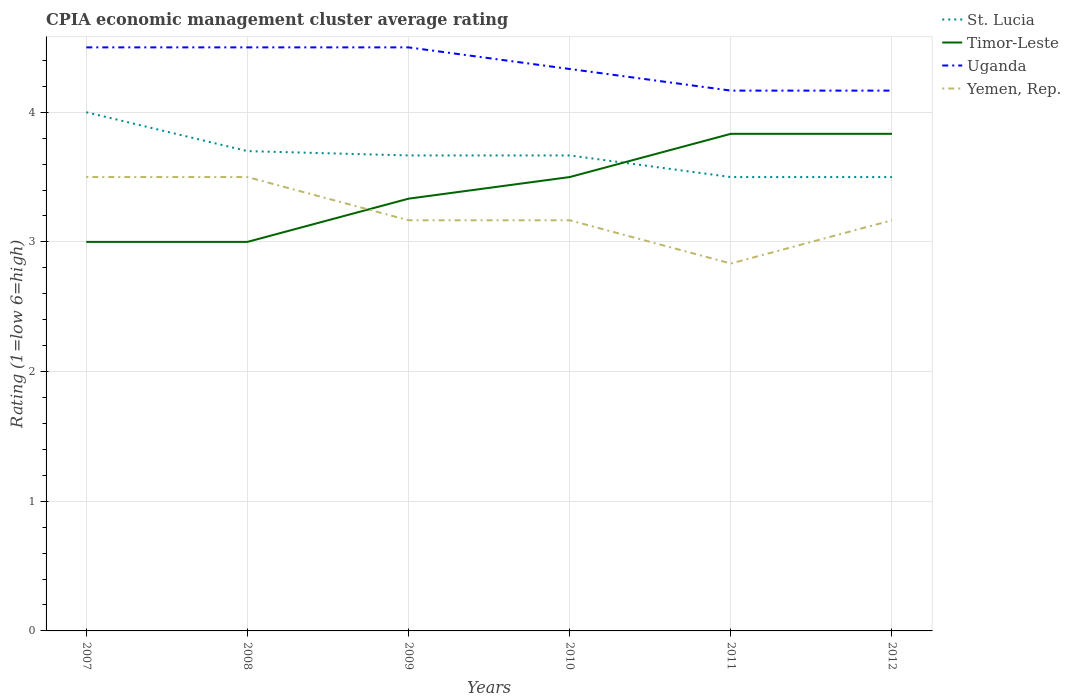How many different coloured lines are there?
Give a very brief answer. 4. Across all years, what is the maximum CPIA rating in St. Lucia?
Offer a very short reply. 3.5. In which year was the CPIA rating in Yemen, Rep. maximum?
Offer a very short reply. 2011. What is the total CPIA rating in Uganda in the graph?
Give a very brief answer. 0.33. What is the difference between the highest and the second highest CPIA rating in Uganda?
Provide a short and direct response. 0.33. What is the difference between the highest and the lowest CPIA rating in Timor-Leste?
Ensure brevity in your answer.  3. Is the CPIA rating in Uganda strictly greater than the CPIA rating in Yemen, Rep. over the years?
Offer a very short reply. No. What is the difference between two consecutive major ticks on the Y-axis?
Keep it short and to the point. 1. Are the values on the major ticks of Y-axis written in scientific E-notation?
Your answer should be very brief. No. Does the graph contain any zero values?
Provide a short and direct response. No. Does the graph contain grids?
Offer a terse response. Yes. Where does the legend appear in the graph?
Provide a succinct answer. Top right. What is the title of the graph?
Offer a terse response. CPIA economic management cluster average rating. What is the label or title of the Y-axis?
Offer a terse response. Rating (1=low 6=high). What is the Rating (1=low 6=high) of Timor-Leste in 2007?
Your answer should be compact. 3. What is the Rating (1=low 6=high) in Yemen, Rep. in 2007?
Make the answer very short. 3.5. What is the Rating (1=low 6=high) in St. Lucia in 2008?
Offer a terse response. 3.7. What is the Rating (1=low 6=high) of Timor-Leste in 2008?
Make the answer very short. 3. What is the Rating (1=low 6=high) in Yemen, Rep. in 2008?
Your answer should be compact. 3.5. What is the Rating (1=low 6=high) in St. Lucia in 2009?
Ensure brevity in your answer.  3.67. What is the Rating (1=low 6=high) of Timor-Leste in 2009?
Make the answer very short. 3.33. What is the Rating (1=low 6=high) of Uganda in 2009?
Provide a succinct answer. 4.5. What is the Rating (1=low 6=high) of Yemen, Rep. in 2009?
Your answer should be very brief. 3.17. What is the Rating (1=low 6=high) in St. Lucia in 2010?
Keep it short and to the point. 3.67. What is the Rating (1=low 6=high) in Timor-Leste in 2010?
Ensure brevity in your answer.  3.5. What is the Rating (1=low 6=high) of Uganda in 2010?
Your answer should be compact. 4.33. What is the Rating (1=low 6=high) in Yemen, Rep. in 2010?
Your answer should be very brief. 3.17. What is the Rating (1=low 6=high) of St. Lucia in 2011?
Give a very brief answer. 3.5. What is the Rating (1=low 6=high) of Timor-Leste in 2011?
Make the answer very short. 3.83. What is the Rating (1=low 6=high) of Uganda in 2011?
Offer a very short reply. 4.17. What is the Rating (1=low 6=high) in Yemen, Rep. in 2011?
Your answer should be very brief. 2.83. What is the Rating (1=low 6=high) in St. Lucia in 2012?
Your response must be concise. 3.5. What is the Rating (1=low 6=high) in Timor-Leste in 2012?
Provide a succinct answer. 3.83. What is the Rating (1=low 6=high) of Uganda in 2012?
Provide a short and direct response. 4.17. What is the Rating (1=low 6=high) of Yemen, Rep. in 2012?
Your answer should be very brief. 3.17. Across all years, what is the maximum Rating (1=low 6=high) of Timor-Leste?
Give a very brief answer. 3.83. Across all years, what is the maximum Rating (1=low 6=high) of Uganda?
Offer a very short reply. 4.5. Across all years, what is the maximum Rating (1=low 6=high) of Yemen, Rep.?
Make the answer very short. 3.5. Across all years, what is the minimum Rating (1=low 6=high) of St. Lucia?
Make the answer very short. 3.5. Across all years, what is the minimum Rating (1=low 6=high) in Timor-Leste?
Your response must be concise. 3. Across all years, what is the minimum Rating (1=low 6=high) of Uganda?
Make the answer very short. 4.17. Across all years, what is the minimum Rating (1=low 6=high) in Yemen, Rep.?
Offer a terse response. 2.83. What is the total Rating (1=low 6=high) of St. Lucia in the graph?
Your answer should be very brief. 22.03. What is the total Rating (1=low 6=high) in Timor-Leste in the graph?
Your answer should be very brief. 20.5. What is the total Rating (1=low 6=high) in Uganda in the graph?
Offer a very short reply. 26.17. What is the total Rating (1=low 6=high) in Yemen, Rep. in the graph?
Offer a very short reply. 19.33. What is the difference between the Rating (1=low 6=high) in Uganda in 2007 and that in 2008?
Offer a terse response. 0. What is the difference between the Rating (1=low 6=high) in Timor-Leste in 2007 and that in 2009?
Keep it short and to the point. -0.33. What is the difference between the Rating (1=low 6=high) in Yemen, Rep. in 2007 and that in 2009?
Provide a short and direct response. 0.33. What is the difference between the Rating (1=low 6=high) of Timor-Leste in 2007 and that in 2010?
Give a very brief answer. -0.5. What is the difference between the Rating (1=low 6=high) in St. Lucia in 2007 and that in 2011?
Ensure brevity in your answer.  0.5. What is the difference between the Rating (1=low 6=high) of Yemen, Rep. in 2007 and that in 2011?
Give a very brief answer. 0.67. What is the difference between the Rating (1=low 6=high) in Timor-Leste in 2007 and that in 2012?
Your answer should be very brief. -0.83. What is the difference between the Rating (1=low 6=high) of St. Lucia in 2008 and that in 2009?
Your response must be concise. 0.03. What is the difference between the Rating (1=low 6=high) of Timor-Leste in 2008 and that in 2009?
Keep it short and to the point. -0.33. What is the difference between the Rating (1=low 6=high) of St. Lucia in 2008 and that in 2010?
Give a very brief answer. 0.03. What is the difference between the Rating (1=low 6=high) of Yemen, Rep. in 2008 and that in 2011?
Your response must be concise. 0.67. What is the difference between the Rating (1=low 6=high) of Timor-Leste in 2008 and that in 2012?
Give a very brief answer. -0.83. What is the difference between the Rating (1=low 6=high) of Uganda in 2008 and that in 2012?
Make the answer very short. 0.33. What is the difference between the Rating (1=low 6=high) in St. Lucia in 2009 and that in 2010?
Your answer should be very brief. 0. What is the difference between the Rating (1=low 6=high) of Uganda in 2009 and that in 2010?
Provide a short and direct response. 0.17. What is the difference between the Rating (1=low 6=high) in Yemen, Rep. in 2009 and that in 2010?
Your answer should be compact. 0. What is the difference between the Rating (1=low 6=high) in Timor-Leste in 2009 and that in 2012?
Your response must be concise. -0.5. What is the difference between the Rating (1=low 6=high) in St. Lucia in 2010 and that in 2011?
Offer a terse response. 0.17. What is the difference between the Rating (1=low 6=high) in Yemen, Rep. in 2010 and that in 2011?
Keep it short and to the point. 0.33. What is the difference between the Rating (1=low 6=high) in Yemen, Rep. in 2010 and that in 2012?
Ensure brevity in your answer.  0. What is the difference between the Rating (1=low 6=high) in St. Lucia in 2011 and that in 2012?
Your answer should be very brief. 0. What is the difference between the Rating (1=low 6=high) of St. Lucia in 2007 and the Rating (1=low 6=high) of Timor-Leste in 2008?
Offer a very short reply. 1. What is the difference between the Rating (1=low 6=high) of St. Lucia in 2007 and the Rating (1=low 6=high) of Uganda in 2008?
Your answer should be very brief. -0.5. What is the difference between the Rating (1=low 6=high) of St. Lucia in 2007 and the Rating (1=low 6=high) of Yemen, Rep. in 2008?
Your response must be concise. 0.5. What is the difference between the Rating (1=low 6=high) in Timor-Leste in 2007 and the Rating (1=low 6=high) in Uganda in 2008?
Your answer should be very brief. -1.5. What is the difference between the Rating (1=low 6=high) of Uganda in 2007 and the Rating (1=low 6=high) of Yemen, Rep. in 2008?
Your response must be concise. 1. What is the difference between the Rating (1=low 6=high) of St. Lucia in 2007 and the Rating (1=low 6=high) of Uganda in 2009?
Ensure brevity in your answer.  -0.5. What is the difference between the Rating (1=low 6=high) of St. Lucia in 2007 and the Rating (1=low 6=high) of Yemen, Rep. in 2009?
Ensure brevity in your answer.  0.83. What is the difference between the Rating (1=low 6=high) of St. Lucia in 2007 and the Rating (1=low 6=high) of Timor-Leste in 2010?
Your answer should be very brief. 0.5. What is the difference between the Rating (1=low 6=high) of St. Lucia in 2007 and the Rating (1=low 6=high) of Yemen, Rep. in 2010?
Make the answer very short. 0.83. What is the difference between the Rating (1=low 6=high) of Timor-Leste in 2007 and the Rating (1=low 6=high) of Uganda in 2010?
Ensure brevity in your answer.  -1.33. What is the difference between the Rating (1=low 6=high) of Timor-Leste in 2007 and the Rating (1=low 6=high) of Yemen, Rep. in 2010?
Give a very brief answer. -0.17. What is the difference between the Rating (1=low 6=high) in Timor-Leste in 2007 and the Rating (1=low 6=high) in Uganda in 2011?
Provide a succinct answer. -1.17. What is the difference between the Rating (1=low 6=high) of St. Lucia in 2007 and the Rating (1=low 6=high) of Uganda in 2012?
Provide a short and direct response. -0.17. What is the difference between the Rating (1=low 6=high) of Timor-Leste in 2007 and the Rating (1=low 6=high) of Uganda in 2012?
Your answer should be very brief. -1.17. What is the difference between the Rating (1=low 6=high) in Uganda in 2007 and the Rating (1=low 6=high) in Yemen, Rep. in 2012?
Give a very brief answer. 1.33. What is the difference between the Rating (1=low 6=high) of St. Lucia in 2008 and the Rating (1=low 6=high) of Timor-Leste in 2009?
Offer a very short reply. 0.37. What is the difference between the Rating (1=low 6=high) in St. Lucia in 2008 and the Rating (1=low 6=high) in Yemen, Rep. in 2009?
Your answer should be very brief. 0.53. What is the difference between the Rating (1=low 6=high) of Uganda in 2008 and the Rating (1=low 6=high) of Yemen, Rep. in 2009?
Your answer should be compact. 1.33. What is the difference between the Rating (1=low 6=high) of St. Lucia in 2008 and the Rating (1=low 6=high) of Timor-Leste in 2010?
Give a very brief answer. 0.2. What is the difference between the Rating (1=low 6=high) of St. Lucia in 2008 and the Rating (1=low 6=high) of Uganda in 2010?
Offer a terse response. -0.63. What is the difference between the Rating (1=low 6=high) of St. Lucia in 2008 and the Rating (1=low 6=high) of Yemen, Rep. in 2010?
Your response must be concise. 0.53. What is the difference between the Rating (1=low 6=high) of Timor-Leste in 2008 and the Rating (1=low 6=high) of Uganda in 2010?
Your response must be concise. -1.33. What is the difference between the Rating (1=low 6=high) in St. Lucia in 2008 and the Rating (1=low 6=high) in Timor-Leste in 2011?
Make the answer very short. -0.13. What is the difference between the Rating (1=low 6=high) of St. Lucia in 2008 and the Rating (1=low 6=high) of Uganda in 2011?
Offer a very short reply. -0.47. What is the difference between the Rating (1=low 6=high) of St. Lucia in 2008 and the Rating (1=low 6=high) of Yemen, Rep. in 2011?
Your answer should be compact. 0.87. What is the difference between the Rating (1=low 6=high) in Timor-Leste in 2008 and the Rating (1=low 6=high) in Uganda in 2011?
Provide a succinct answer. -1.17. What is the difference between the Rating (1=low 6=high) of Timor-Leste in 2008 and the Rating (1=low 6=high) of Yemen, Rep. in 2011?
Make the answer very short. 0.17. What is the difference between the Rating (1=low 6=high) in Uganda in 2008 and the Rating (1=low 6=high) in Yemen, Rep. in 2011?
Keep it short and to the point. 1.67. What is the difference between the Rating (1=low 6=high) of St. Lucia in 2008 and the Rating (1=low 6=high) of Timor-Leste in 2012?
Keep it short and to the point. -0.13. What is the difference between the Rating (1=low 6=high) in St. Lucia in 2008 and the Rating (1=low 6=high) in Uganda in 2012?
Provide a short and direct response. -0.47. What is the difference between the Rating (1=low 6=high) of St. Lucia in 2008 and the Rating (1=low 6=high) of Yemen, Rep. in 2012?
Your answer should be very brief. 0.53. What is the difference between the Rating (1=low 6=high) of Timor-Leste in 2008 and the Rating (1=low 6=high) of Uganda in 2012?
Make the answer very short. -1.17. What is the difference between the Rating (1=low 6=high) in Timor-Leste in 2008 and the Rating (1=low 6=high) in Yemen, Rep. in 2012?
Offer a very short reply. -0.17. What is the difference between the Rating (1=low 6=high) of Uganda in 2008 and the Rating (1=low 6=high) of Yemen, Rep. in 2012?
Give a very brief answer. 1.33. What is the difference between the Rating (1=low 6=high) in St. Lucia in 2009 and the Rating (1=low 6=high) in Uganda in 2010?
Offer a very short reply. -0.67. What is the difference between the Rating (1=low 6=high) of St. Lucia in 2009 and the Rating (1=low 6=high) of Yemen, Rep. in 2010?
Offer a very short reply. 0.5. What is the difference between the Rating (1=low 6=high) in Timor-Leste in 2009 and the Rating (1=low 6=high) in Yemen, Rep. in 2010?
Offer a very short reply. 0.17. What is the difference between the Rating (1=low 6=high) in Uganda in 2009 and the Rating (1=low 6=high) in Yemen, Rep. in 2010?
Ensure brevity in your answer.  1.33. What is the difference between the Rating (1=low 6=high) in St. Lucia in 2009 and the Rating (1=low 6=high) in Timor-Leste in 2011?
Your answer should be very brief. -0.17. What is the difference between the Rating (1=low 6=high) in St. Lucia in 2009 and the Rating (1=low 6=high) in Uganda in 2011?
Make the answer very short. -0.5. What is the difference between the Rating (1=low 6=high) in St. Lucia in 2009 and the Rating (1=low 6=high) in Yemen, Rep. in 2011?
Offer a terse response. 0.83. What is the difference between the Rating (1=low 6=high) of Timor-Leste in 2009 and the Rating (1=low 6=high) of Uganda in 2011?
Give a very brief answer. -0.83. What is the difference between the Rating (1=low 6=high) of Timor-Leste in 2009 and the Rating (1=low 6=high) of Yemen, Rep. in 2011?
Your answer should be very brief. 0.5. What is the difference between the Rating (1=low 6=high) in Uganda in 2009 and the Rating (1=low 6=high) in Yemen, Rep. in 2011?
Offer a terse response. 1.67. What is the difference between the Rating (1=low 6=high) in St. Lucia in 2009 and the Rating (1=low 6=high) in Timor-Leste in 2012?
Offer a very short reply. -0.17. What is the difference between the Rating (1=low 6=high) in St. Lucia in 2009 and the Rating (1=low 6=high) in Uganda in 2012?
Offer a terse response. -0.5. What is the difference between the Rating (1=low 6=high) in St. Lucia in 2009 and the Rating (1=low 6=high) in Yemen, Rep. in 2012?
Offer a terse response. 0.5. What is the difference between the Rating (1=low 6=high) in Uganda in 2009 and the Rating (1=low 6=high) in Yemen, Rep. in 2012?
Your answer should be compact. 1.33. What is the difference between the Rating (1=low 6=high) in St. Lucia in 2010 and the Rating (1=low 6=high) in Timor-Leste in 2011?
Your response must be concise. -0.17. What is the difference between the Rating (1=low 6=high) of St. Lucia in 2010 and the Rating (1=low 6=high) of Timor-Leste in 2012?
Keep it short and to the point. -0.17. What is the difference between the Rating (1=low 6=high) of Timor-Leste in 2010 and the Rating (1=low 6=high) of Uganda in 2012?
Give a very brief answer. -0.67. What is the difference between the Rating (1=low 6=high) in Timor-Leste in 2010 and the Rating (1=low 6=high) in Yemen, Rep. in 2012?
Make the answer very short. 0.33. What is the difference between the Rating (1=low 6=high) of St. Lucia in 2011 and the Rating (1=low 6=high) of Uganda in 2012?
Provide a succinct answer. -0.67. What is the difference between the Rating (1=low 6=high) in St. Lucia in 2011 and the Rating (1=low 6=high) in Yemen, Rep. in 2012?
Offer a very short reply. 0.33. What is the difference between the Rating (1=low 6=high) in Timor-Leste in 2011 and the Rating (1=low 6=high) in Uganda in 2012?
Offer a very short reply. -0.33. What is the average Rating (1=low 6=high) of St. Lucia per year?
Make the answer very short. 3.67. What is the average Rating (1=low 6=high) in Timor-Leste per year?
Provide a short and direct response. 3.42. What is the average Rating (1=low 6=high) of Uganda per year?
Keep it short and to the point. 4.36. What is the average Rating (1=low 6=high) of Yemen, Rep. per year?
Your answer should be compact. 3.22. In the year 2007, what is the difference between the Rating (1=low 6=high) in St. Lucia and Rating (1=low 6=high) in Yemen, Rep.?
Provide a short and direct response. 0.5. In the year 2008, what is the difference between the Rating (1=low 6=high) in St. Lucia and Rating (1=low 6=high) in Timor-Leste?
Your response must be concise. 0.7. In the year 2008, what is the difference between the Rating (1=low 6=high) in Timor-Leste and Rating (1=low 6=high) in Uganda?
Offer a very short reply. -1.5. In the year 2008, what is the difference between the Rating (1=low 6=high) in Timor-Leste and Rating (1=low 6=high) in Yemen, Rep.?
Ensure brevity in your answer.  -0.5. In the year 2008, what is the difference between the Rating (1=low 6=high) in Uganda and Rating (1=low 6=high) in Yemen, Rep.?
Provide a succinct answer. 1. In the year 2009, what is the difference between the Rating (1=low 6=high) of St. Lucia and Rating (1=low 6=high) of Timor-Leste?
Your answer should be compact. 0.33. In the year 2009, what is the difference between the Rating (1=low 6=high) in St. Lucia and Rating (1=low 6=high) in Uganda?
Provide a succinct answer. -0.83. In the year 2009, what is the difference between the Rating (1=low 6=high) of Timor-Leste and Rating (1=low 6=high) of Uganda?
Your answer should be compact. -1.17. In the year 2009, what is the difference between the Rating (1=low 6=high) in Timor-Leste and Rating (1=low 6=high) in Yemen, Rep.?
Offer a very short reply. 0.17. In the year 2009, what is the difference between the Rating (1=low 6=high) of Uganda and Rating (1=low 6=high) of Yemen, Rep.?
Your answer should be very brief. 1.33. In the year 2010, what is the difference between the Rating (1=low 6=high) in St. Lucia and Rating (1=low 6=high) in Yemen, Rep.?
Offer a terse response. 0.5. In the year 2010, what is the difference between the Rating (1=low 6=high) in Timor-Leste and Rating (1=low 6=high) in Uganda?
Your response must be concise. -0.83. In the year 2011, what is the difference between the Rating (1=low 6=high) in St. Lucia and Rating (1=low 6=high) in Timor-Leste?
Give a very brief answer. -0.33. In the year 2011, what is the difference between the Rating (1=low 6=high) of St. Lucia and Rating (1=low 6=high) of Uganda?
Give a very brief answer. -0.67. In the year 2011, what is the difference between the Rating (1=low 6=high) in Timor-Leste and Rating (1=low 6=high) in Uganda?
Provide a short and direct response. -0.33. In the year 2011, what is the difference between the Rating (1=low 6=high) of Timor-Leste and Rating (1=low 6=high) of Yemen, Rep.?
Ensure brevity in your answer.  1. In the year 2012, what is the difference between the Rating (1=low 6=high) in Timor-Leste and Rating (1=low 6=high) in Uganda?
Your response must be concise. -0.33. What is the ratio of the Rating (1=low 6=high) in St. Lucia in 2007 to that in 2008?
Make the answer very short. 1.08. What is the ratio of the Rating (1=low 6=high) of Timor-Leste in 2007 to that in 2008?
Give a very brief answer. 1. What is the ratio of the Rating (1=low 6=high) of Uganda in 2007 to that in 2008?
Keep it short and to the point. 1. What is the ratio of the Rating (1=low 6=high) in Yemen, Rep. in 2007 to that in 2009?
Offer a terse response. 1.11. What is the ratio of the Rating (1=low 6=high) in St. Lucia in 2007 to that in 2010?
Give a very brief answer. 1.09. What is the ratio of the Rating (1=low 6=high) in Uganda in 2007 to that in 2010?
Offer a very short reply. 1.04. What is the ratio of the Rating (1=low 6=high) in Yemen, Rep. in 2007 to that in 2010?
Your response must be concise. 1.11. What is the ratio of the Rating (1=low 6=high) of St. Lucia in 2007 to that in 2011?
Give a very brief answer. 1.14. What is the ratio of the Rating (1=low 6=high) of Timor-Leste in 2007 to that in 2011?
Offer a terse response. 0.78. What is the ratio of the Rating (1=low 6=high) in Uganda in 2007 to that in 2011?
Keep it short and to the point. 1.08. What is the ratio of the Rating (1=low 6=high) in Yemen, Rep. in 2007 to that in 2011?
Your answer should be very brief. 1.24. What is the ratio of the Rating (1=low 6=high) of Timor-Leste in 2007 to that in 2012?
Your response must be concise. 0.78. What is the ratio of the Rating (1=low 6=high) of Uganda in 2007 to that in 2012?
Make the answer very short. 1.08. What is the ratio of the Rating (1=low 6=high) of Yemen, Rep. in 2007 to that in 2012?
Provide a succinct answer. 1.11. What is the ratio of the Rating (1=low 6=high) in St. Lucia in 2008 to that in 2009?
Your answer should be very brief. 1.01. What is the ratio of the Rating (1=low 6=high) of Uganda in 2008 to that in 2009?
Your answer should be very brief. 1. What is the ratio of the Rating (1=low 6=high) of Yemen, Rep. in 2008 to that in 2009?
Give a very brief answer. 1.11. What is the ratio of the Rating (1=low 6=high) in St. Lucia in 2008 to that in 2010?
Give a very brief answer. 1.01. What is the ratio of the Rating (1=low 6=high) in Yemen, Rep. in 2008 to that in 2010?
Provide a succinct answer. 1.11. What is the ratio of the Rating (1=low 6=high) of St. Lucia in 2008 to that in 2011?
Make the answer very short. 1.06. What is the ratio of the Rating (1=low 6=high) of Timor-Leste in 2008 to that in 2011?
Your answer should be very brief. 0.78. What is the ratio of the Rating (1=low 6=high) in Uganda in 2008 to that in 2011?
Ensure brevity in your answer.  1.08. What is the ratio of the Rating (1=low 6=high) in Yemen, Rep. in 2008 to that in 2011?
Offer a very short reply. 1.24. What is the ratio of the Rating (1=low 6=high) of St. Lucia in 2008 to that in 2012?
Your answer should be very brief. 1.06. What is the ratio of the Rating (1=low 6=high) in Timor-Leste in 2008 to that in 2012?
Ensure brevity in your answer.  0.78. What is the ratio of the Rating (1=low 6=high) of Yemen, Rep. in 2008 to that in 2012?
Provide a succinct answer. 1.11. What is the ratio of the Rating (1=low 6=high) of Timor-Leste in 2009 to that in 2010?
Make the answer very short. 0.95. What is the ratio of the Rating (1=low 6=high) in Yemen, Rep. in 2009 to that in 2010?
Ensure brevity in your answer.  1. What is the ratio of the Rating (1=low 6=high) of St. Lucia in 2009 to that in 2011?
Your response must be concise. 1.05. What is the ratio of the Rating (1=low 6=high) of Timor-Leste in 2009 to that in 2011?
Give a very brief answer. 0.87. What is the ratio of the Rating (1=low 6=high) in Yemen, Rep. in 2009 to that in 2011?
Make the answer very short. 1.12. What is the ratio of the Rating (1=low 6=high) in St. Lucia in 2009 to that in 2012?
Offer a very short reply. 1.05. What is the ratio of the Rating (1=low 6=high) of Timor-Leste in 2009 to that in 2012?
Provide a succinct answer. 0.87. What is the ratio of the Rating (1=low 6=high) in Uganda in 2009 to that in 2012?
Keep it short and to the point. 1.08. What is the ratio of the Rating (1=low 6=high) of Yemen, Rep. in 2009 to that in 2012?
Keep it short and to the point. 1. What is the ratio of the Rating (1=low 6=high) of St. Lucia in 2010 to that in 2011?
Keep it short and to the point. 1.05. What is the ratio of the Rating (1=low 6=high) in Yemen, Rep. in 2010 to that in 2011?
Offer a terse response. 1.12. What is the ratio of the Rating (1=low 6=high) in St. Lucia in 2010 to that in 2012?
Offer a terse response. 1.05. What is the ratio of the Rating (1=low 6=high) of Yemen, Rep. in 2010 to that in 2012?
Your answer should be compact. 1. What is the ratio of the Rating (1=low 6=high) in St. Lucia in 2011 to that in 2012?
Provide a short and direct response. 1. What is the ratio of the Rating (1=low 6=high) in Uganda in 2011 to that in 2012?
Give a very brief answer. 1. What is the ratio of the Rating (1=low 6=high) in Yemen, Rep. in 2011 to that in 2012?
Your response must be concise. 0.89. 